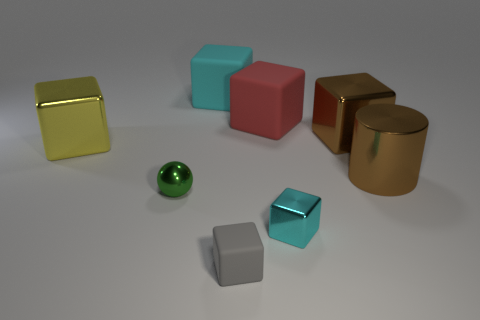Can you describe the colors and textures of the objects seen in the image? Certainly! In the image, there are objects with various colors and textures. To start with, we have a cube with a shiny gold surface and another with a glossy turquoise hue. There's also a red cube with a matte finish. A cylindrical object appears with a reflective golden surface, while another object, a sphere, has a shiny green texture. Lastly, there's a small cube with a satin silver finish. The diversity in color and texture adds visual interest to the scene. 